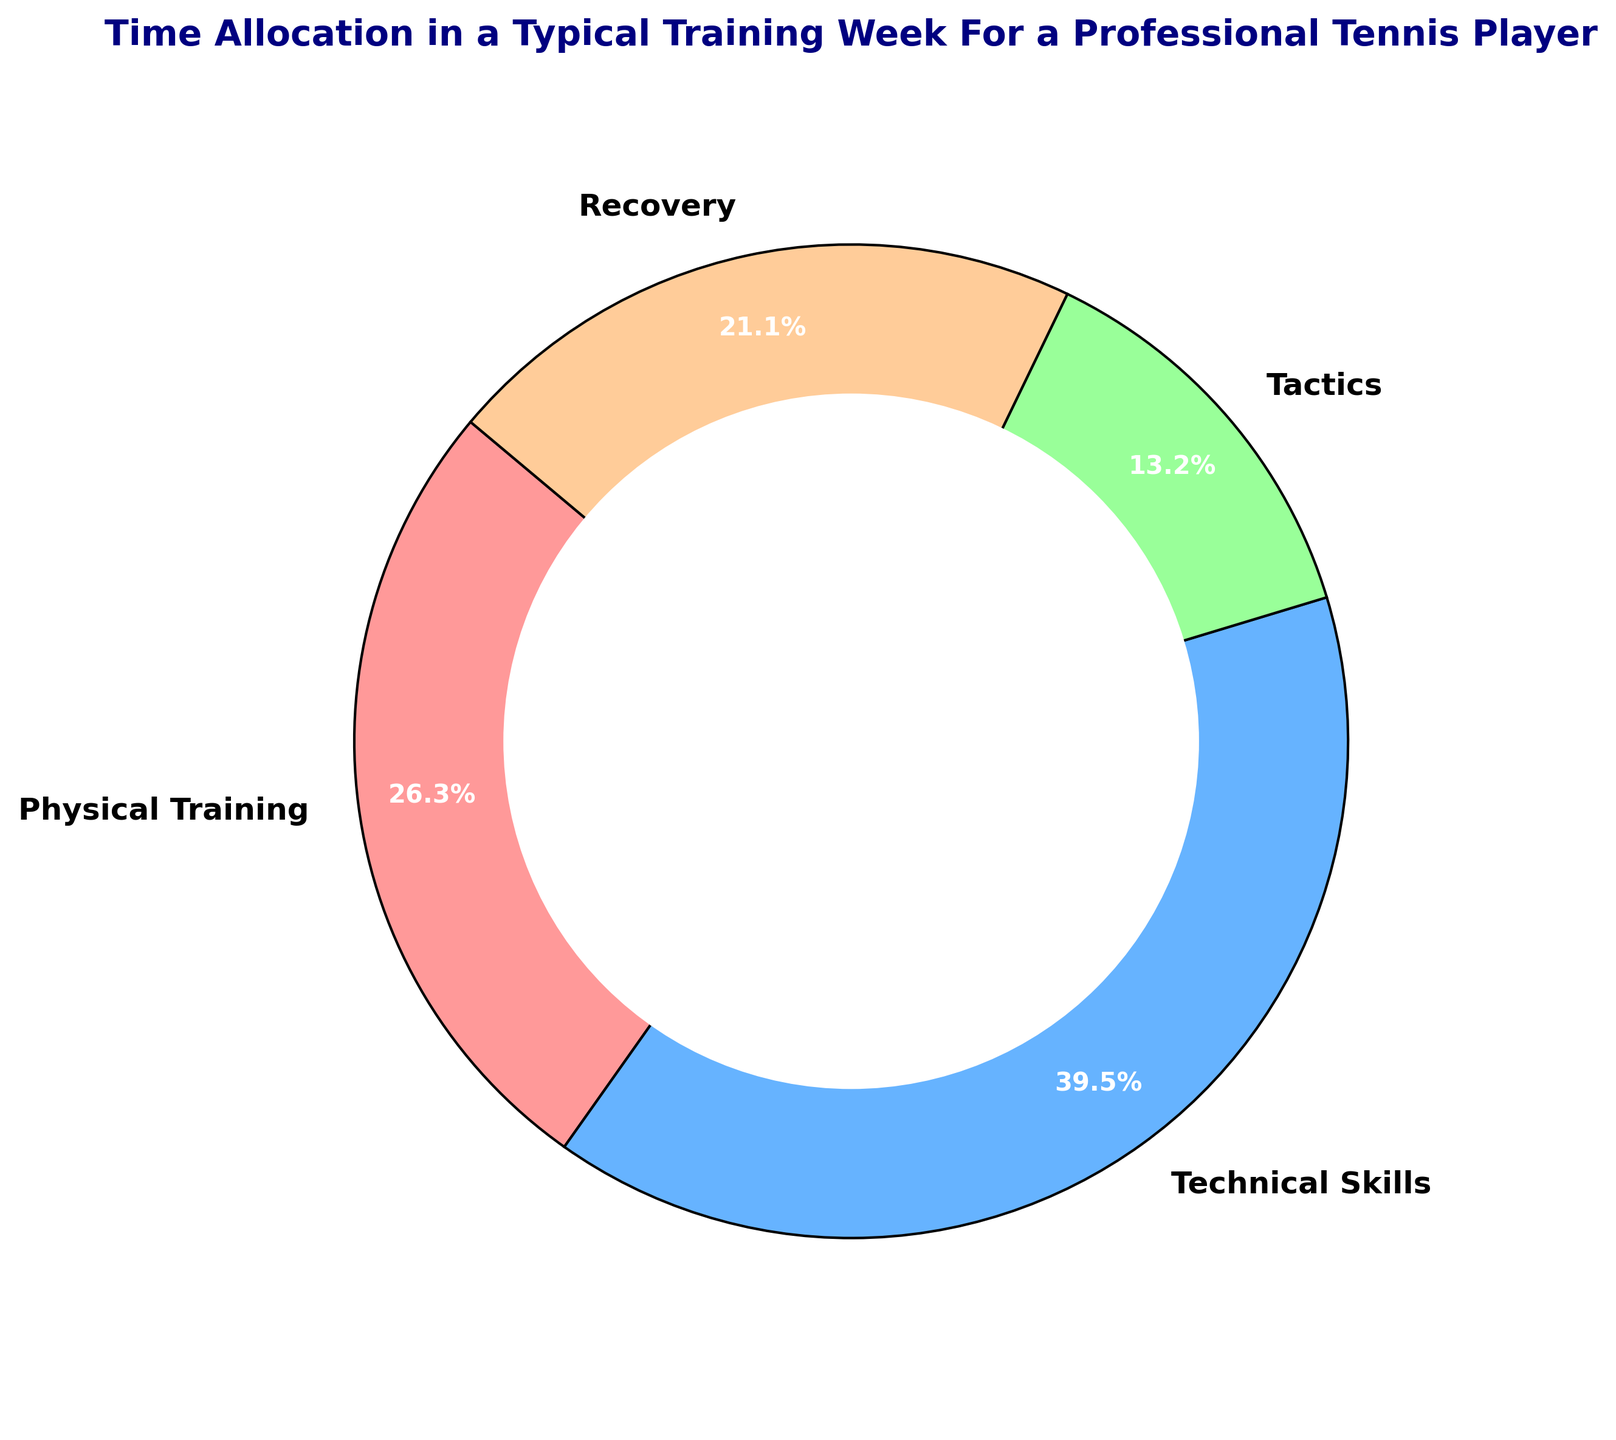What percentage of the time is dedicated to Recovery? The pie chart segments illustrate the proportion of hours allocated to each training category. Recovery is one segment of this chart. Reading the label on the Recovery segment, you can see that it is specifically labeled with its percentage.
Answer: 23.5% Which training category is allocated the most hours in a typical training week? By examining the size of each segment in the pie chart, you can identify which segment is the largest. The segment labeled Technical Skills occupies a greater portion of the circle than any other segment.
Answer: Technical Skills What is the combined percentage of time spent on Physical Training and Tactics? To determine this, add the percentages of both Physical Training and Tactics by looking at their respective segments in the pie chart. Physical Training is 29.4% and Tactics is 14.7%. Summing these values gives you the combined percentage.
Answer: 44.1% Compare the time spent on Technical Skills and Recovery. Which one is greater and by how much? Observing the segments for Technical Skills and Recovery in the pie chart, note their respective percentages (44.1% for Technical Skills and 23.5% for Recovery). Subtract the smaller percentage from the larger one to find the difference.
Answer: Technical Skills, by 20.6% If the total time available for training is increased by 10 hours while maintaining the same proportions, how many additional hours would be allocated to Recovery? First calculate the new total training hours (38 + 10 = 48). Recovery represents 23.5% of training time. Multiply 48 by 23.5% to find the new hours (48 * 0.235 = 11.28). Subtract the current Recovery hours (8) from this value (11.28 - 8).
Answer: 3.28 hours What percentage of time is not dedicated to Physical Training? To determine this, subtract the percentage of time dedicated to Physical Training from 100%. The percentage for Physical Training is 29.4%. Performing the subtraction (100% - 29.4%) gives you the percentage of time not dedicated to Physical Training.
Answer: 70.6% How does the time allocation for Tactics compare to Physical Training? Look at the pie chart and locate the segments for Tactics and Physical Training. Note their respective percentages: Tactics is 14.7% and Physical Training is 29.4%. Comparing these values shows that Physical Training has a higher percentage than Tactics.
Answer: Physical Training is higher by 14.7% What fraction of the week is spent on Technical Skills? Examine the pie chart and find the segment for Technical Skills. The chart shows Technical Skills taking up 44.1% of the week. Converting this percentage to a fraction involves dividing by 100 (44.1 / 100).
Answer: 44.1/100, or approximately 44/100 